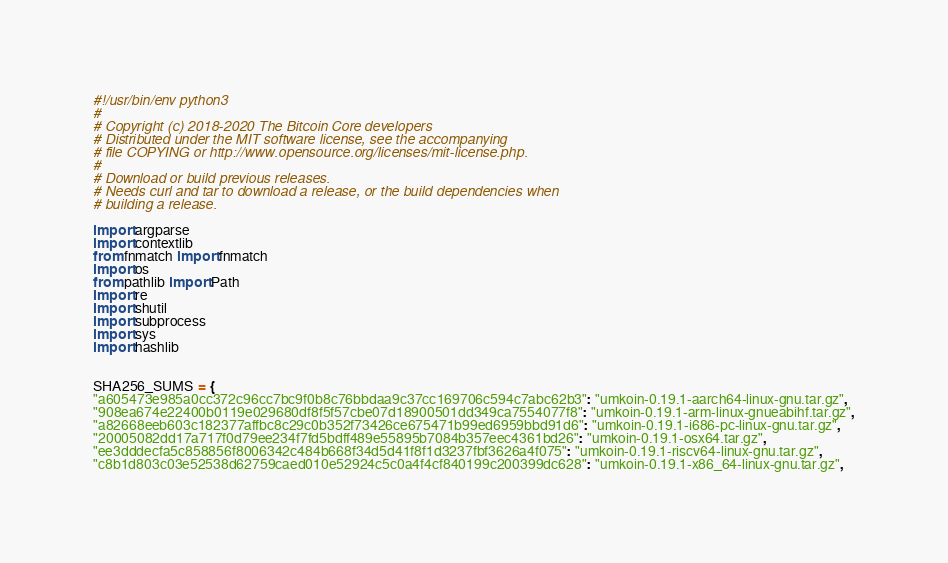<code> <loc_0><loc_0><loc_500><loc_500><_Python_>#!/usr/bin/env python3
#
# Copyright (c) 2018-2020 The Bitcoin Core developers
# Distributed under the MIT software license, see the accompanying
# file COPYING or http://www.opensource.org/licenses/mit-license.php.
#
# Download or build previous releases.
# Needs curl and tar to download a release, or the build dependencies when
# building a release.

import argparse
import contextlib
from fnmatch import fnmatch
import os
from pathlib import Path
import re
import shutil
import subprocess
import sys
import hashlib


SHA256_SUMS = {
"a605473e985a0cc372c96cc7bc9f0b8c76bbdaa9c37cc169706c594c7abc62b3": "umkoin-0.19.1-aarch64-linux-gnu.tar.gz",
"908ea674e22400b0119e029680df8f5f57cbe07d18900501dd349ca7554077f8": "umkoin-0.19.1-arm-linux-gnueabihf.tar.gz",
"a82668eeb603c182377affbc8c29c0b352f73426ce675471b99ed6959bbd91d6": "umkoin-0.19.1-i686-pc-linux-gnu.tar.gz",
"20005082dd17a717f0d79ee234f7fd5bdff489e55895b7084b357eec4361bd26": "umkoin-0.19.1-osx64.tar.gz",
"ee3dddecfa5c858856f8006342c484b668f34d5d41f8f1d3237fbf3626a4f075": "umkoin-0.19.1-riscv64-linux-gnu.tar.gz",
"c8b1d803c03e52538d62759caed010e52924c5c0a4f4cf840199c200399dc628": "umkoin-0.19.1-x86_64-linux-gnu.tar.gz",
</code> 